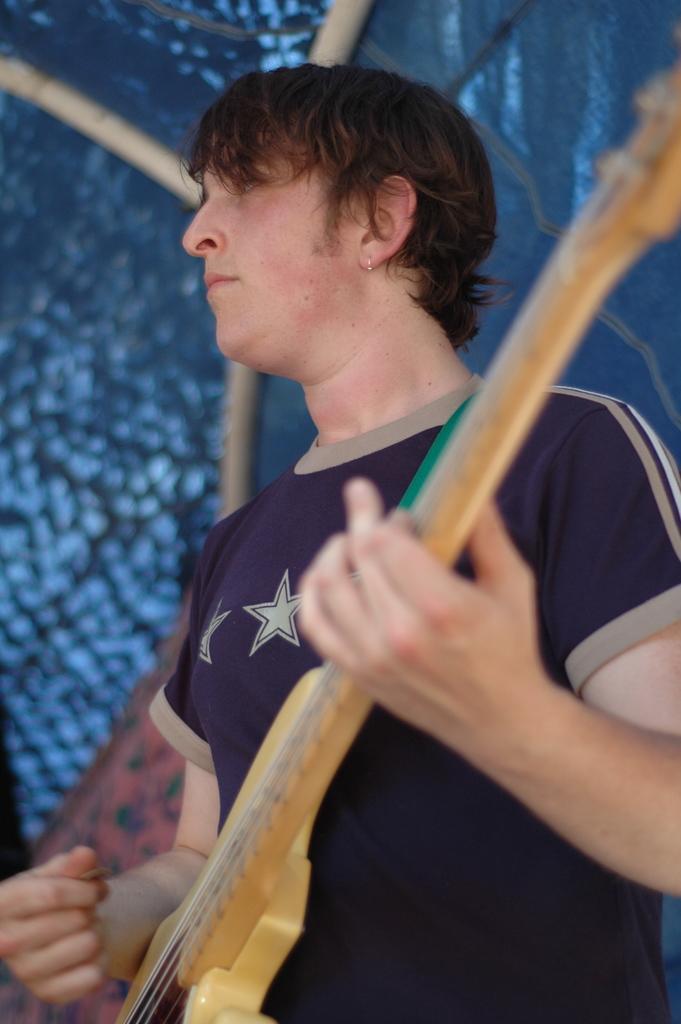Could you give a brief overview of what you see in this image? in the picture ,there was a person holding guitar and standing,back of the person we can see a pole. 